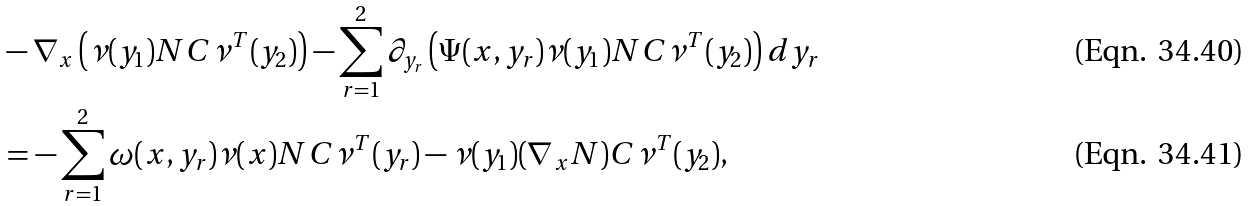<formula> <loc_0><loc_0><loc_500><loc_500>& - \nabla _ { x } \left ( \nu ( y _ { 1 } ) N C \nu ^ { T } ( y _ { 2 } ) \right ) - \sum _ { r = 1 } ^ { 2 } \partial _ { y _ { r } } \left ( \Psi ( x , y _ { r } ) \nu ( y _ { 1 } ) N C \nu ^ { T } ( y _ { 2 } ) \right ) d y _ { r } \\ & = - \sum _ { r = 1 } ^ { 2 } \omega ( x , y _ { r } ) \nu ( x ) N C \nu ^ { T } ( y _ { r } ) - \nu ( y _ { 1 } ) ( \nabla _ { x } N ) C \nu ^ { T } ( y _ { 2 } ) ,</formula> 